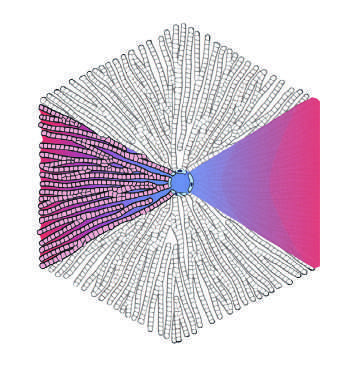s the terminal hepatic vein at the center of a lobule, while the portal tracts are at the periphery in the lobular model?
Answer the question using a single word or phrase. Yes 